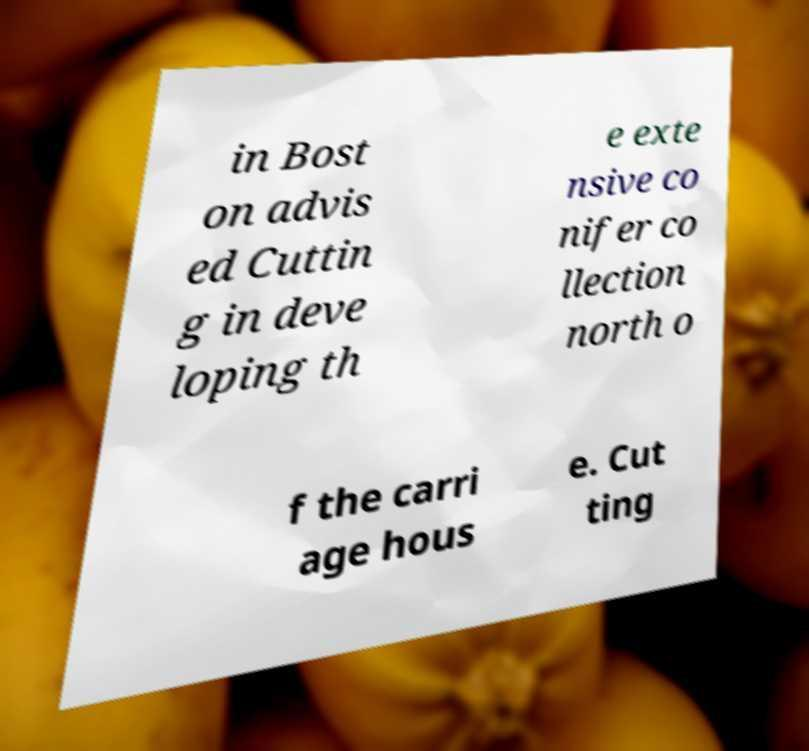What messages or text are displayed in this image? I need them in a readable, typed format. in Bost on advis ed Cuttin g in deve loping th e exte nsive co nifer co llection north o f the carri age hous e. Cut ting 